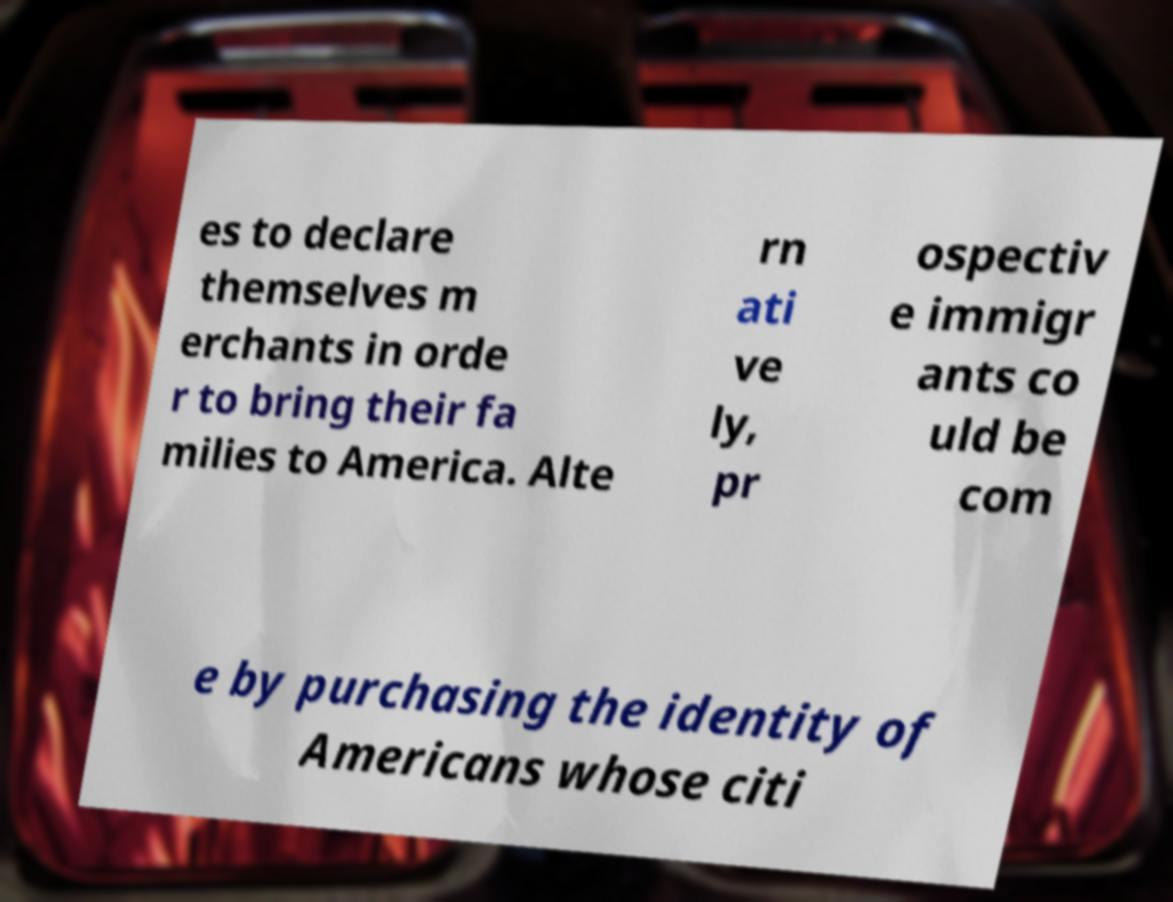Can you read and provide the text displayed in the image?This photo seems to have some interesting text. Can you extract and type it out for me? es to declare themselves m erchants in orde r to bring their fa milies to America. Alte rn ati ve ly, pr ospectiv e immigr ants co uld be com e by purchasing the identity of Americans whose citi 